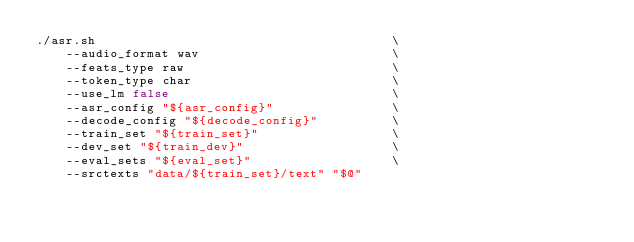Convert code to text. <code><loc_0><loc_0><loc_500><loc_500><_Bash_>./asr.sh                                        \
    --audio_format wav                          \
    --feats_type raw                            \
    --token_type char                           \
    --use_lm false                              \
    --asr_config "${asr_config}"                \
    --decode_config "${decode_config}"          \
    --train_set "${train_set}"                  \
    --dev_set "${train_dev}"                    \
    --eval_sets "${eval_set}"                   \
    --srctexts "data/${train_set}/text" "$@"
</code> 